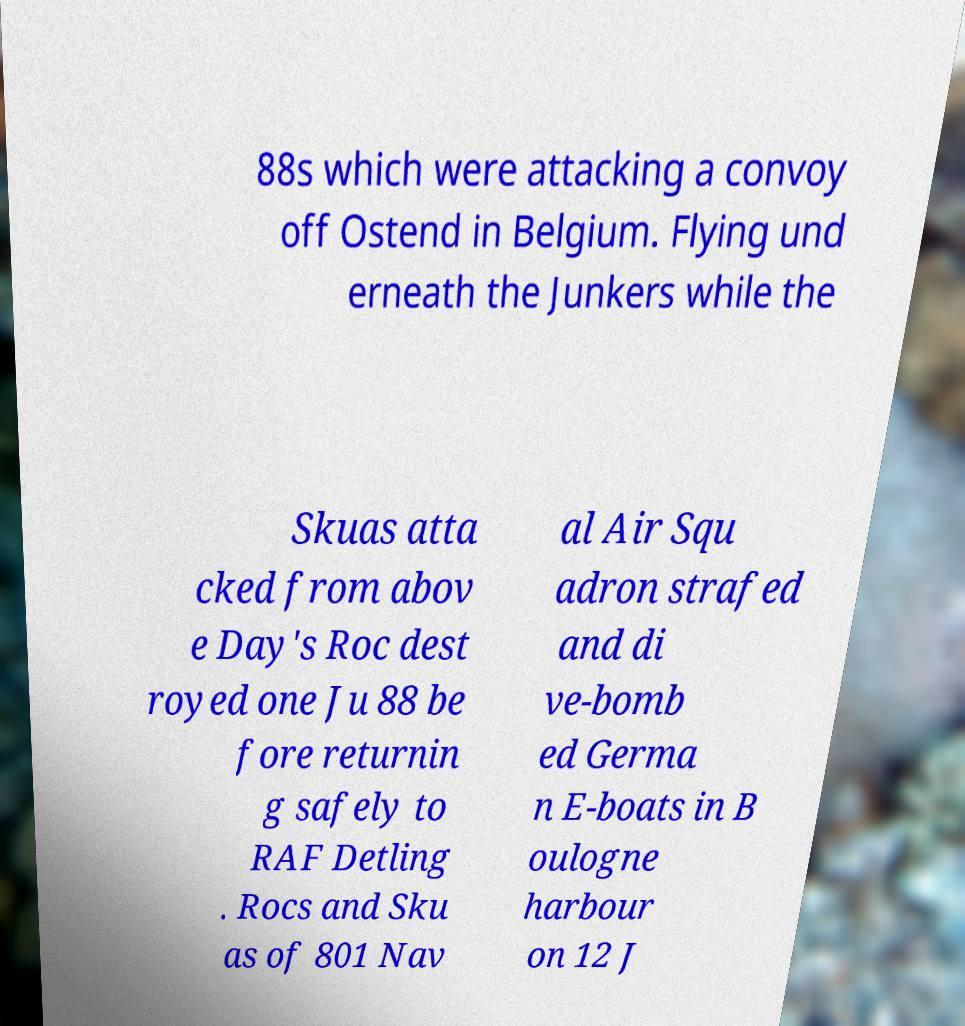Could you assist in decoding the text presented in this image and type it out clearly? 88s which were attacking a convoy off Ostend in Belgium. Flying und erneath the Junkers while the Skuas atta cked from abov e Day's Roc dest royed one Ju 88 be fore returnin g safely to RAF Detling . Rocs and Sku as of 801 Nav al Air Squ adron strafed and di ve-bomb ed Germa n E-boats in B oulogne harbour on 12 J 